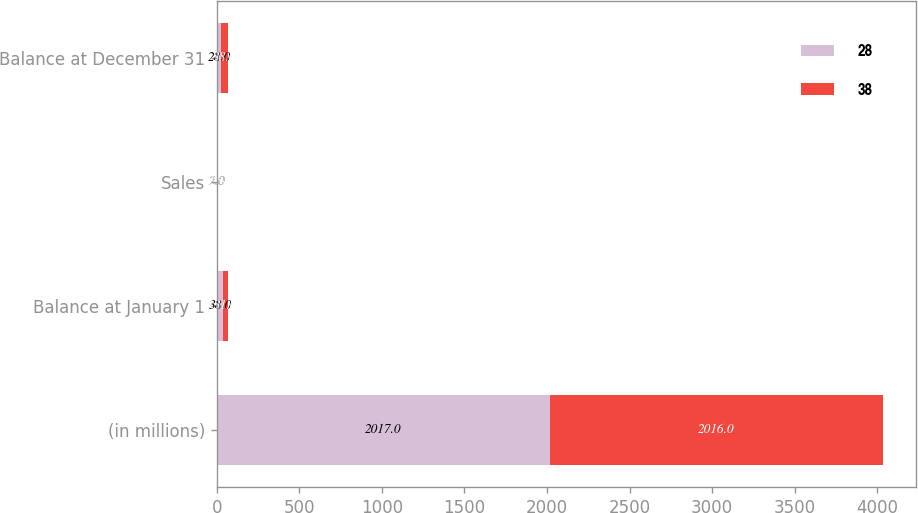<chart> <loc_0><loc_0><loc_500><loc_500><stacked_bar_chart><ecel><fcel>(in millions)<fcel>Balance at January 1<fcel>Sales<fcel>Balance at December 31<nl><fcel>28<fcel>2017<fcel>38<fcel>2<fcel>28<nl><fcel>38<fcel>2016<fcel>31<fcel>2<fcel>38<nl></chart> 